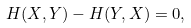<formula> <loc_0><loc_0><loc_500><loc_500>H ( X , Y ) - H ( Y , X ) = 0 ,</formula> 